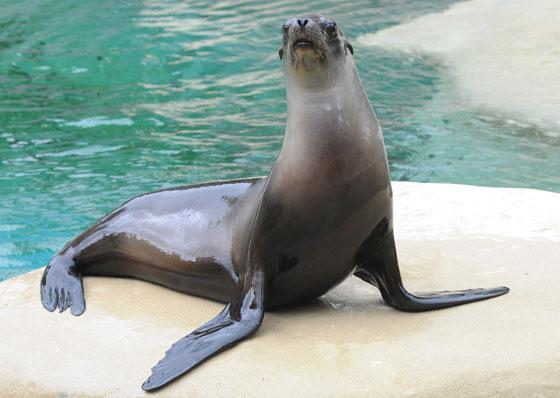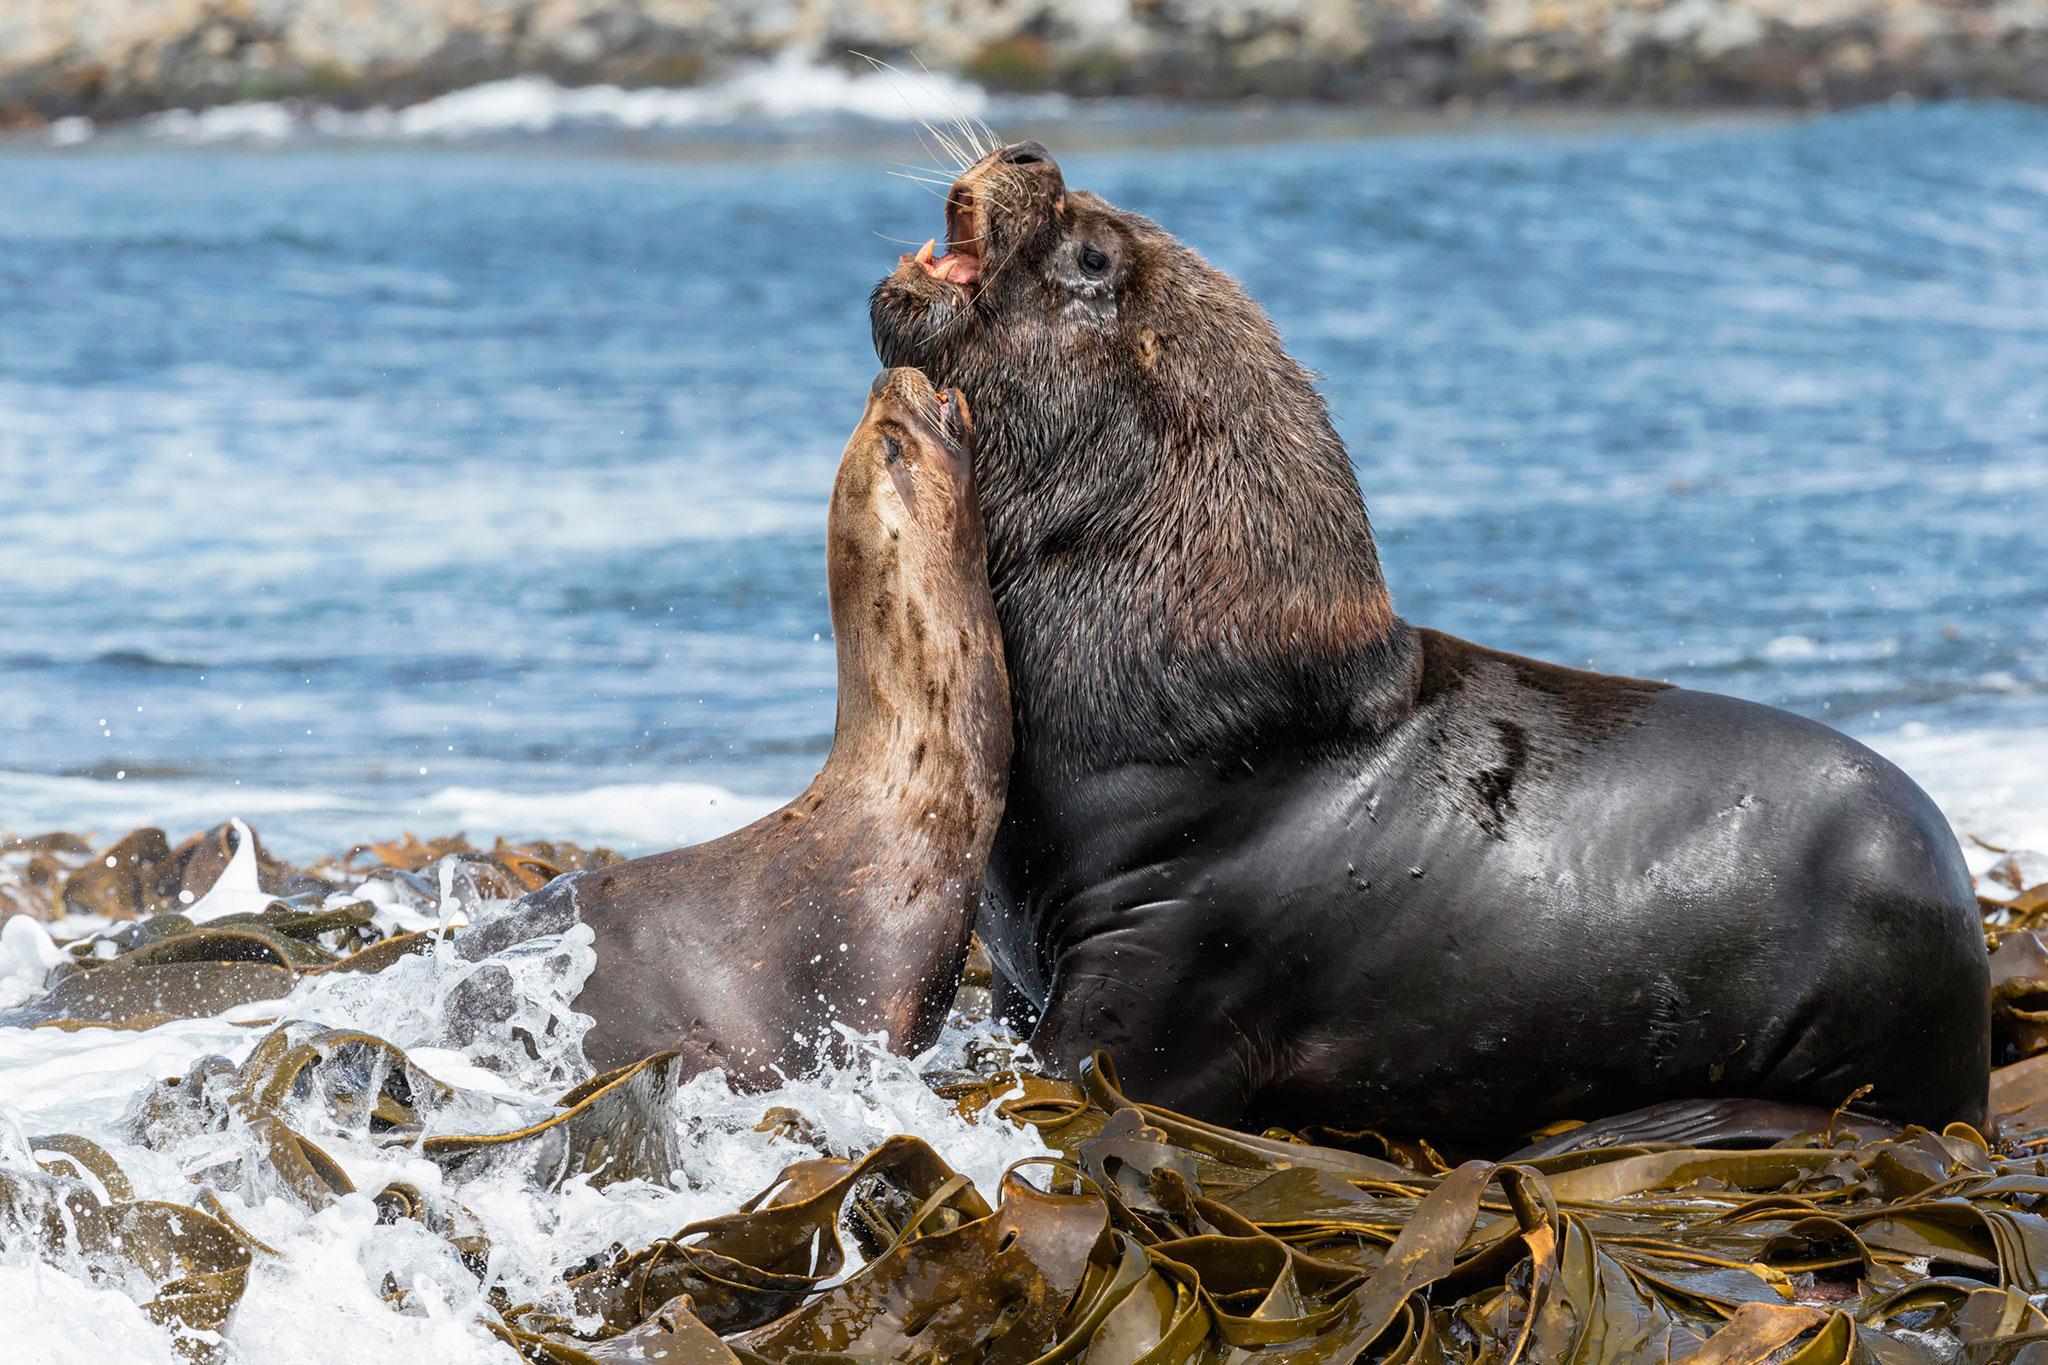The first image is the image on the left, the second image is the image on the right. Evaluate the accuracy of this statement regarding the images: "The seal in the right image is facing right.". Is it true? Answer yes or no. No. 